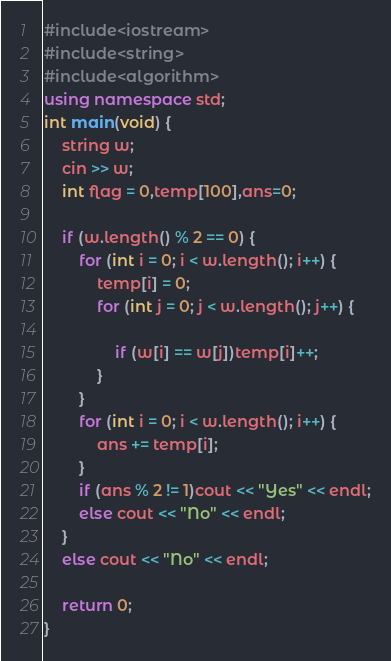Convert code to text. <code><loc_0><loc_0><loc_500><loc_500><_C++_>#include<iostream>
#include<string>
#include<algorithm>
using namespace std;
int main(void) {
	string w;
	cin >> w;
	int flag = 0,temp[100],ans=0;

	if (w.length() % 2 == 0) {
		for (int i = 0; i < w.length(); i++) {
			temp[i] = 0;
			for (int j = 0; j < w.length(); j++) {
				
				if (w[i] == w[j])temp[i]++;
			}
		}
		for (int i = 0; i < w.length(); i++) {
			ans += temp[i];
		}
		if (ans % 2 != 1)cout << "Yes" << endl;
		else cout << "No" << endl;
	}
	else cout << "No" << endl;

	return 0;
}</code> 